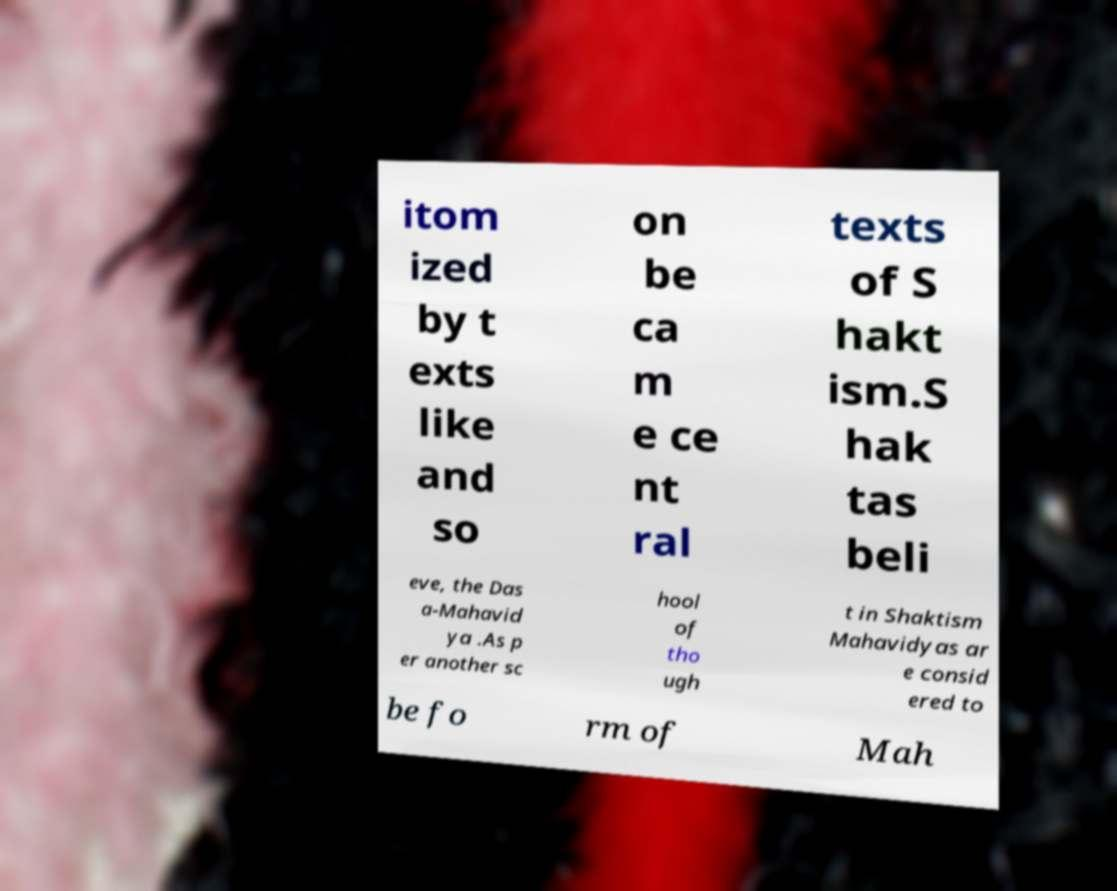Please read and relay the text visible in this image. What does it say? itom ized by t exts like and so on be ca m e ce nt ral texts of S hakt ism.S hak tas beli eve, the Das a-Mahavid ya .As p er another sc hool of tho ugh t in Shaktism Mahavidyas ar e consid ered to be fo rm of Mah 